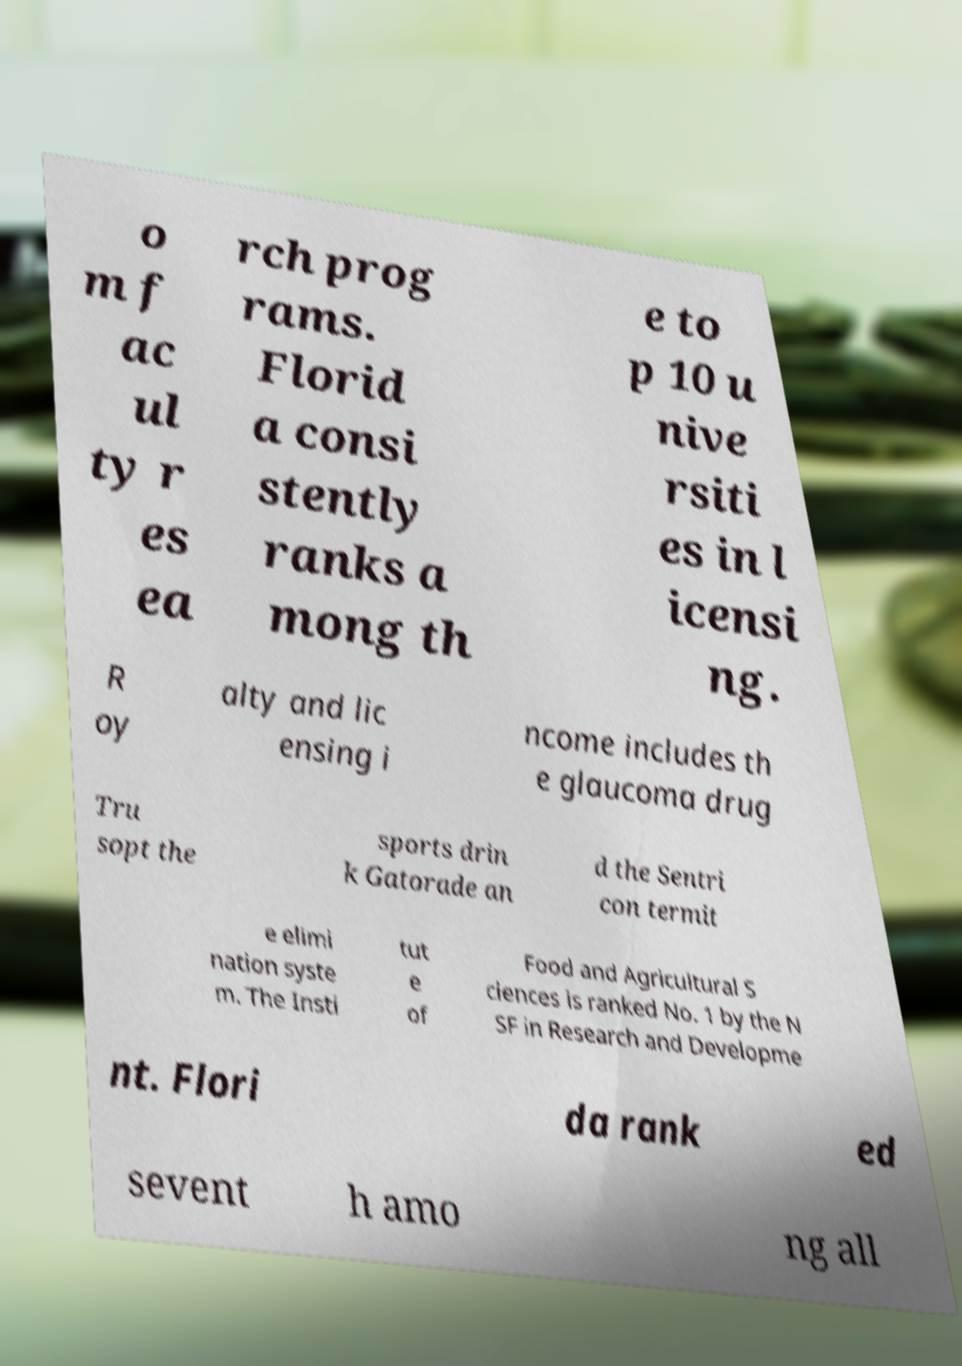What messages or text are displayed in this image? I need them in a readable, typed format. o m f ac ul ty r es ea rch prog rams. Florid a consi stently ranks a mong th e to p 10 u nive rsiti es in l icensi ng. R oy alty and lic ensing i ncome includes th e glaucoma drug Tru sopt the sports drin k Gatorade an d the Sentri con termit e elimi nation syste m. The Insti tut e of Food and Agricultural S ciences is ranked No. 1 by the N SF in Research and Developme nt. Flori da rank ed sevent h amo ng all 